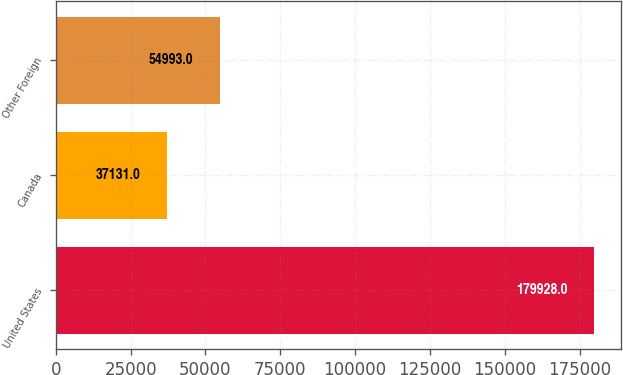<chart> <loc_0><loc_0><loc_500><loc_500><bar_chart><fcel>United States<fcel>Canada<fcel>Other Foreign<nl><fcel>179928<fcel>37131<fcel>54993<nl></chart> 